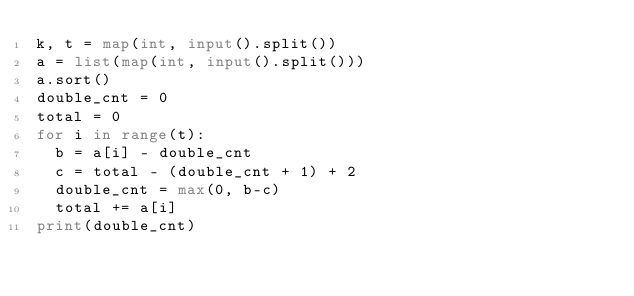Convert code to text. <code><loc_0><loc_0><loc_500><loc_500><_Python_>k, t = map(int, input().split())
a = list(map(int, input().split()))
a.sort()
double_cnt = 0
total = 0
for i in range(t):
  b = a[i] - double_cnt
  c = total - (double_cnt + 1) + 2
  double_cnt = max(0, b-c)
  total += a[i]
print(double_cnt)
</code> 